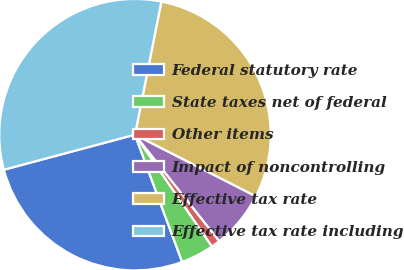<chart> <loc_0><loc_0><loc_500><loc_500><pie_chart><fcel>Federal statutory rate<fcel>State taxes net of federal<fcel>Other items<fcel>Impact of noncontrolling<fcel>Effective tax rate<fcel>Effective tax rate including<nl><fcel>26.49%<fcel>3.95%<fcel>1.06%<fcel>6.84%<fcel>29.38%<fcel>32.27%<nl></chart> 